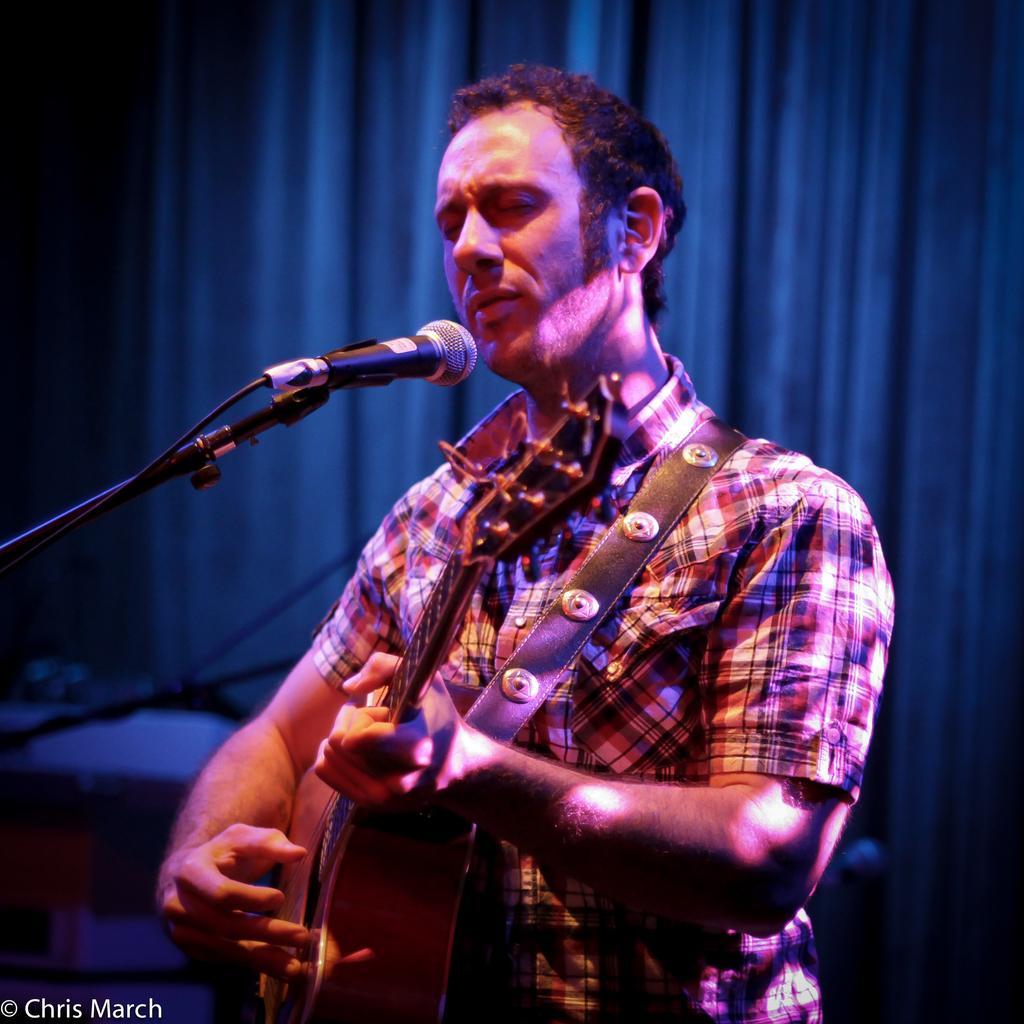Please provide a concise description of this image. In this picture there is a man holding a guitar and playing it. There is also a microphone in front of him, there is a curtain behind him. 